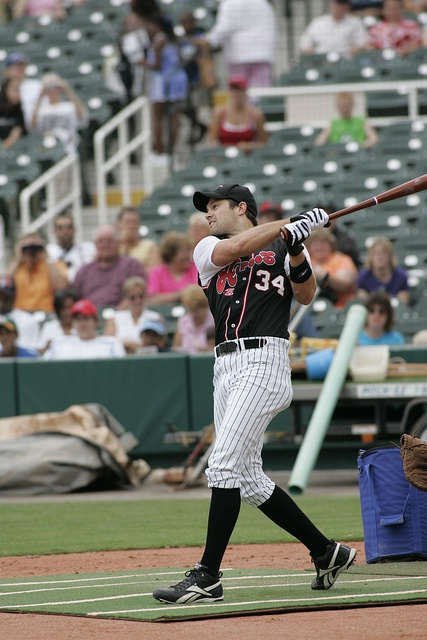Describe the objects in this image and their specific colors. I can see people in gray, black, lightgray, and darkgray tones, people in gray, darkgray, and black tones, people in gray, tan, lightgray, and darkgray tones, people in gray, lightgray, and darkgray tones, and people in gray, black, and tan tones in this image. 